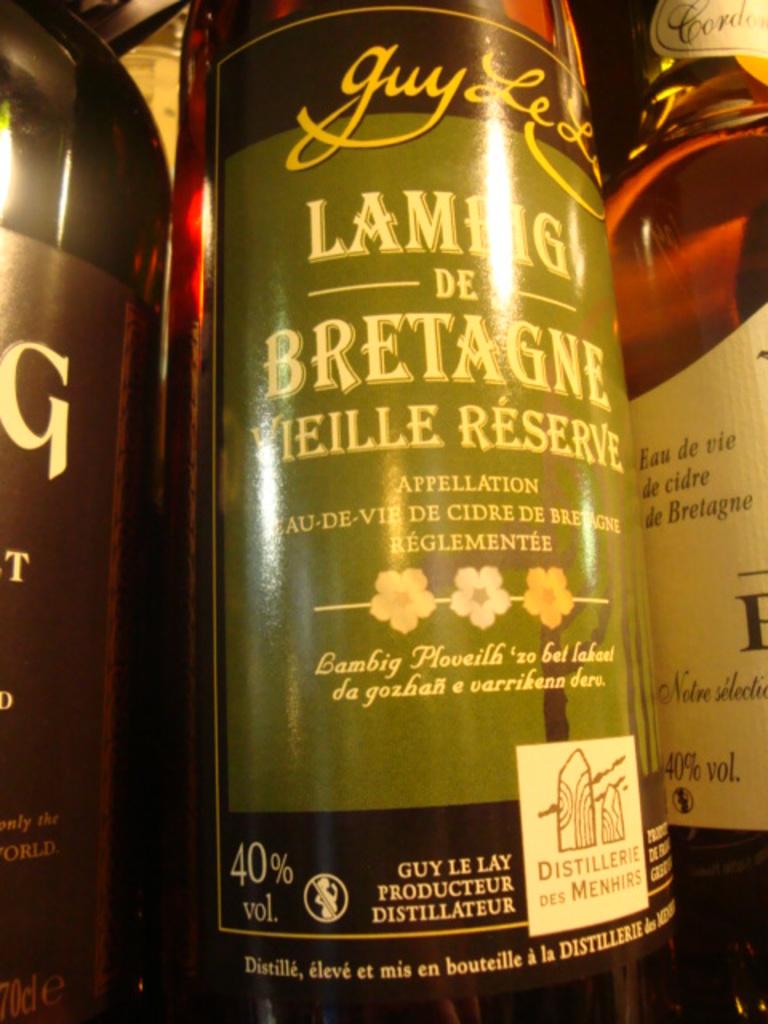What is in the bottle?
Offer a terse response. Unanswerable. 